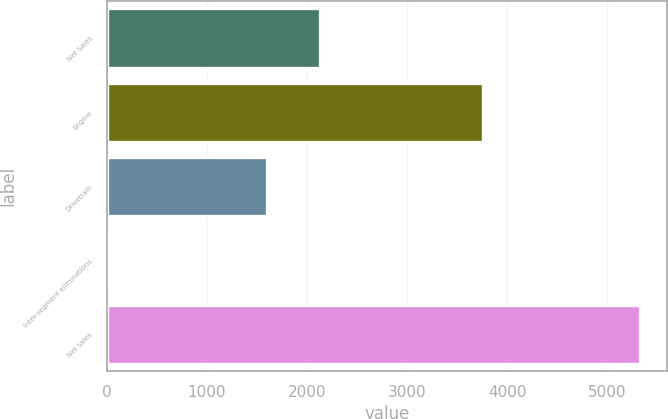Convert chart to OTSL. <chart><loc_0><loc_0><loc_500><loc_500><bar_chart><fcel>Net Sales<fcel>Engine<fcel>Drivetrain<fcel>Inter-segment eliminations<fcel>Net sales<nl><fcel>2128.51<fcel>3761.3<fcel>1598.8<fcel>31.5<fcel>5328.6<nl></chart> 